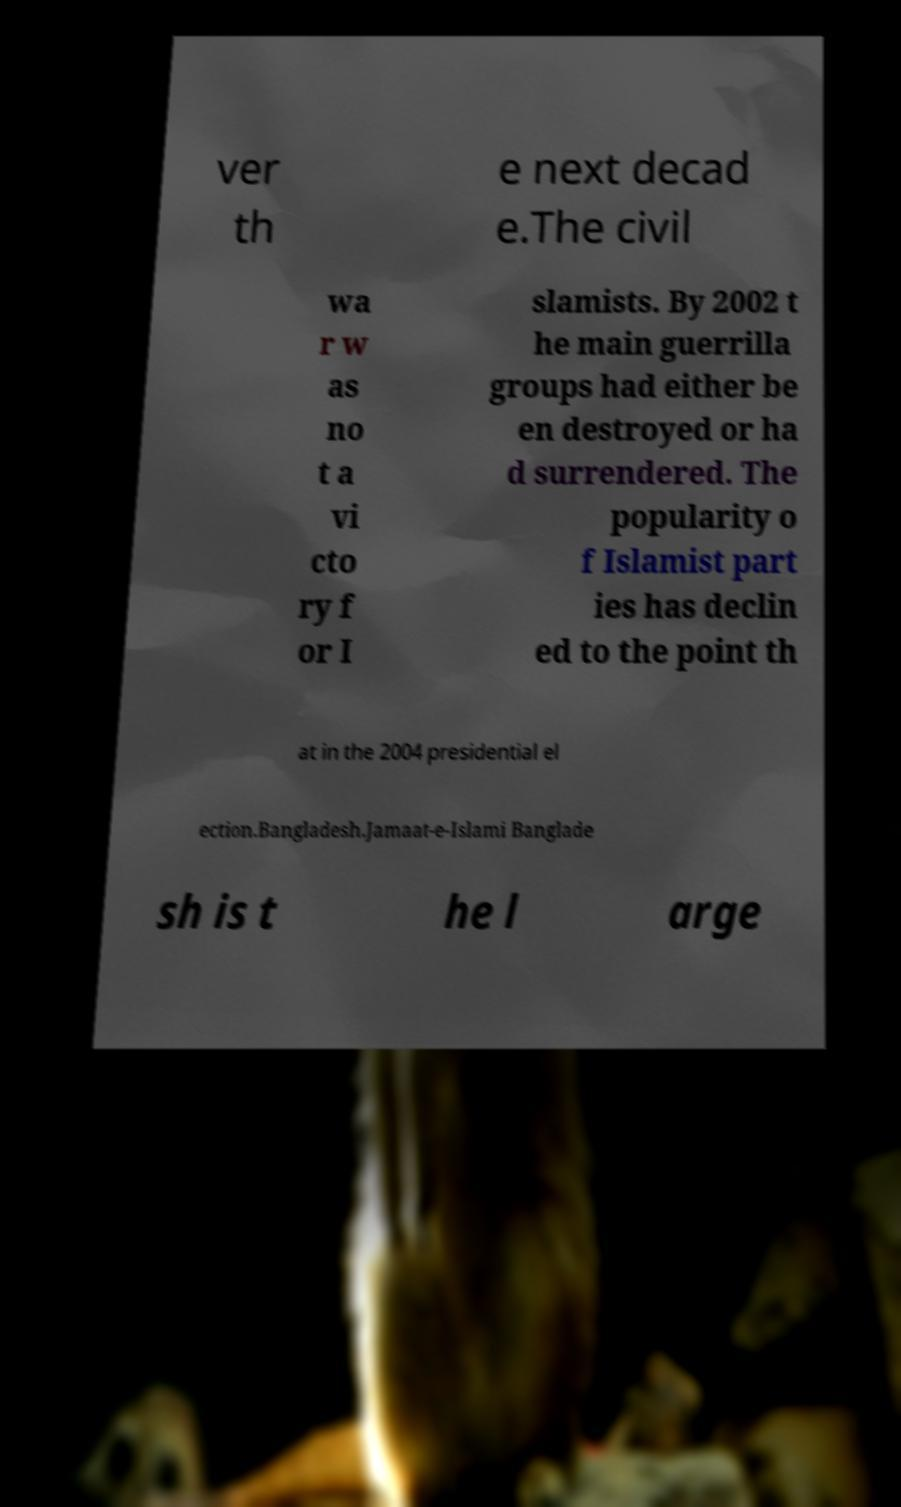For documentation purposes, I need the text within this image transcribed. Could you provide that? ver th e next decad e.The civil wa r w as no t a vi cto ry f or I slamists. By 2002 t he main guerrilla groups had either be en destroyed or ha d surrendered. The popularity o f Islamist part ies has declin ed to the point th at in the 2004 presidential el ection.Bangladesh.Jamaat-e-Islami Banglade sh is t he l arge 